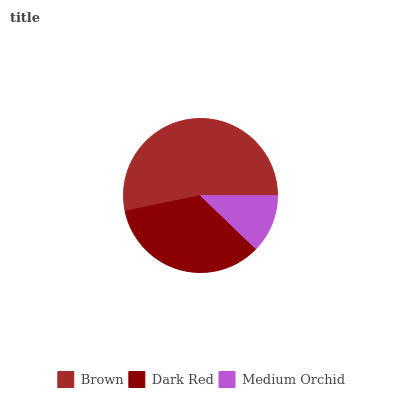Is Medium Orchid the minimum?
Answer yes or no. Yes. Is Brown the maximum?
Answer yes or no. Yes. Is Dark Red the minimum?
Answer yes or no. No. Is Dark Red the maximum?
Answer yes or no. No. Is Brown greater than Dark Red?
Answer yes or no. Yes. Is Dark Red less than Brown?
Answer yes or no. Yes. Is Dark Red greater than Brown?
Answer yes or no. No. Is Brown less than Dark Red?
Answer yes or no. No. Is Dark Red the high median?
Answer yes or no. Yes. Is Dark Red the low median?
Answer yes or no. Yes. Is Medium Orchid the high median?
Answer yes or no. No. Is Brown the low median?
Answer yes or no. No. 